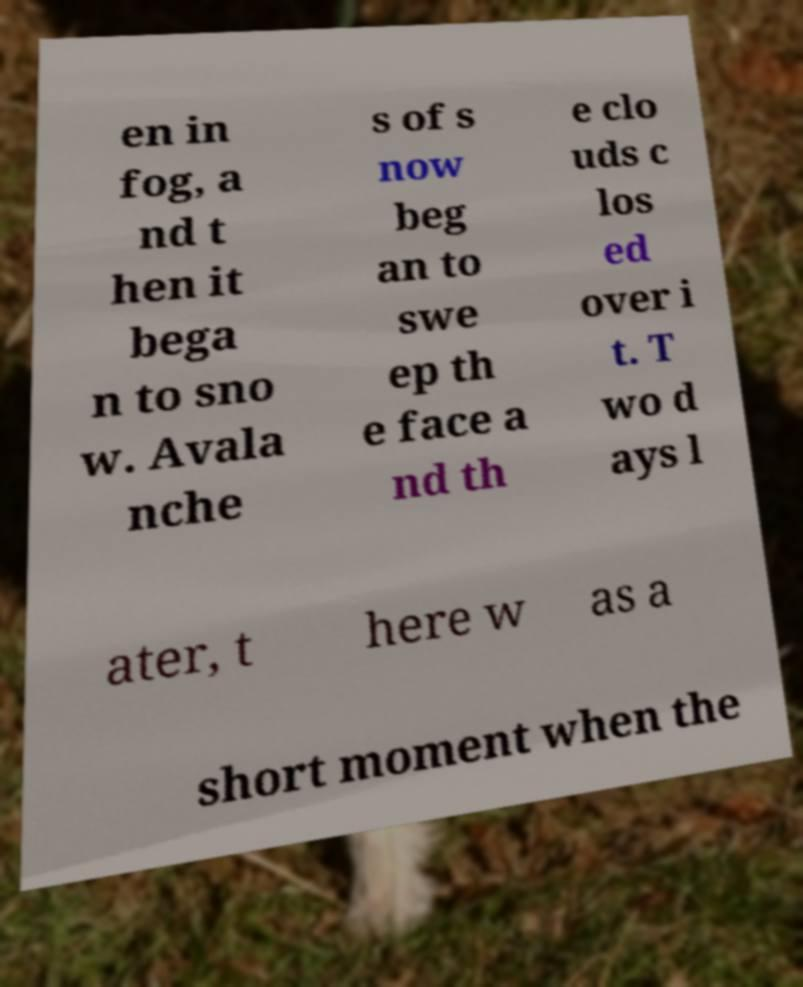Can you accurately transcribe the text from the provided image for me? en in fog, a nd t hen it bega n to sno w. Avala nche s of s now beg an to swe ep th e face a nd th e clo uds c los ed over i t. T wo d ays l ater, t here w as a short moment when the 